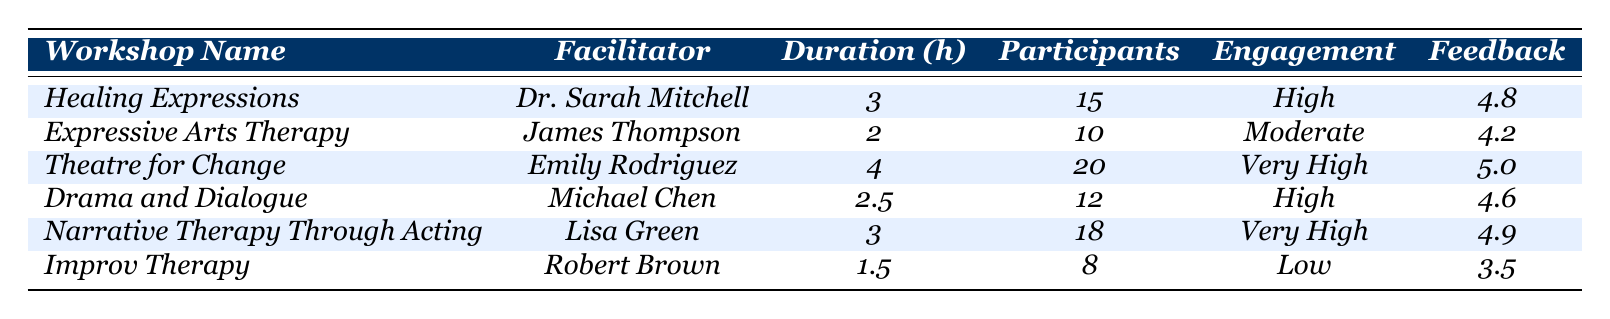What is the feedback score of "Healing Expressions"? The table shows that the feedback score for "Healing Expressions" is listed under the respective column, which is 4.8.
Answer: 4.8 Which workshop had the highest number of participants? By comparing the participants' numbers across all workshops, "Theatre for Change" has the highest number at 20.
Answer: Theatre for Change Is the engagement level of "Improv Therapy" classified as High? Looking at the engagement column, "Improv Therapy" is labeled as Low, which means it is not classified as High.
Answer: No Calculate the average duration of the workshops listed in the table. The total duration is the sum of all workshops: 3 + 2 + 4 + 2.5 + 3 + 1.5 = 16. The number of workshops is 6. Therefore, the average duration is 16/6 = 2.67.
Answer: 2.67 Which workshop achieved a feedback score of 5.0? By examining the feedback scores, "Theatre for Change" is the only workshop that received a perfect score of 5.0.
Answer: Theatre for Change How many workshops have an engagement level of Very High? From the table, "Theatre for Change" and "Narrative Therapy Through Acting" are noted to have an engagement level of Very High—making a total of 2 workshops.
Answer: 2 What is the engagement level of "Narrative Therapy Through Acting"? The engagement level for "Narrative Therapy Through Acting" is specifically listed as Very High in the table.
Answer: Very High Compare the feedback scores of "Expressive Arts Therapy" and "Drama and Dialogue." Which one is higher? The feedback score for "Expressive Arts Therapy" is 4.2, while "Drama and Dialogue" is 4.6. Since 4.6 is greater than 4.2, "Drama and Dialogue" has the higher score.
Answer: Drama and Dialogue What is the total number of participants across all workshops? The total is calculated by summing the number of participants: 15 + 10 + 20 + 12 + 18 + 8 = 93.
Answer: 93 Did more participants take part in workshops with High engagement levels compared to those with Low engagement levels? "High" engagement has 15 (Healing Expressions) + 12 (Drama and Dialogue) = 27 participants; "Low" engagement has 8 (Improv Therapy). Since 27 > 8, more participants took part in High engagement workshops.
Answer: Yes 